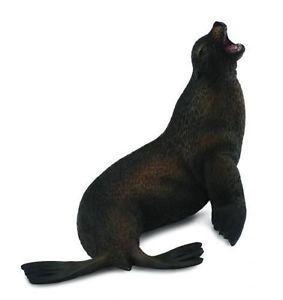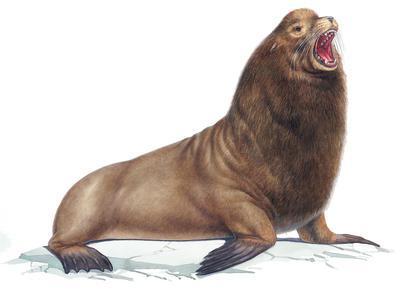The first image is the image on the left, the second image is the image on the right. For the images displayed, is the sentence "The right image has a plain white background." factually correct? Answer yes or no. Yes. 